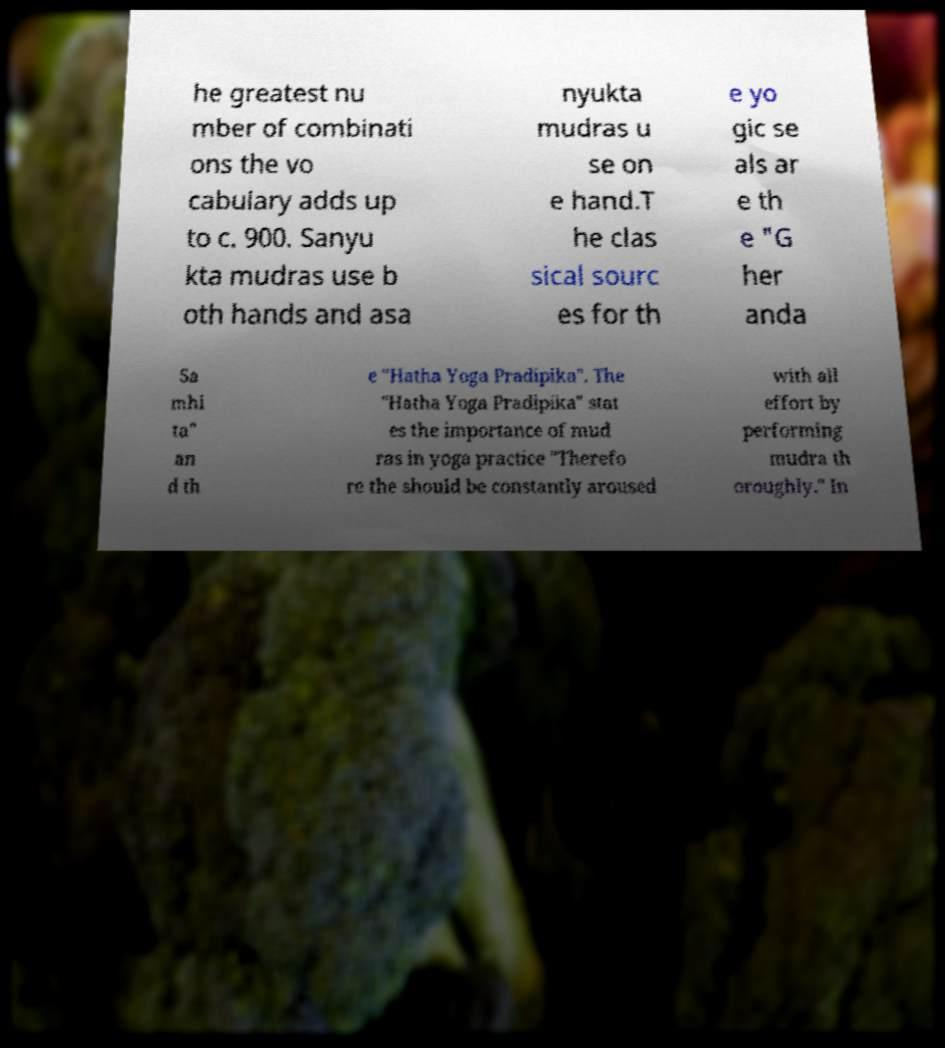There's text embedded in this image that I need extracted. Can you transcribe it verbatim? he greatest nu mber of combinati ons the vo cabulary adds up to c. 900. Sanyu kta mudras use b oth hands and asa nyukta mudras u se on e hand.T he clas sical sourc es for th e yo gic se als ar e th e "G her anda Sa mhi ta" an d th e "Hatha Yoga Pradipika". The "Hatha Yoga Pradipika" stat es the importance of mud ras in yoga practice "Therefo re the should be constantly aroused with all effort by performing mudra th oroughly." In 